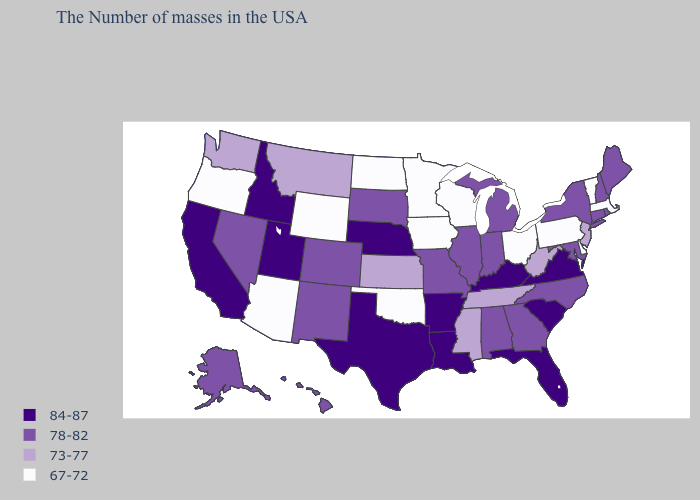Name the states that have a value in the range 84-87?
Write a very short answer. Virginia, South Carolina, Florida, Kentucky, Louisiana, Arkansas, Nebraska, Texas, Utah, Idaho, California. Does South Carolina have the highest value in the USA?
Keep it brief. Yes. What is the value of New Jersey?
Keep it brief. 73-77. What is the value of Nebraska?
Give a very brief answer. 84-87. How many symbols are there in the legend?
Concise answer only. 4. Does Iowa have the lowest value in the MidWest?
Write a very short answer. Yes. Does the first symbol in the legend represent the smallest category?
Keep it brief. No. Does New Jersey have the lowest value in the Northeast?
Short answer required. No. What is the value of Texas?
Write a very short answer. 84-87. Does Indiana have the highest value in the USA?
Be succinct. No. What is the lowest value in states that border Wisconsin?
Keep it brief. 67-72. What is the lowest value in the USA?
Answer briefly. 67-72. Name the states that have a value in the range 78-82?
Quick response, please. Maine, Rhode Island, New Hampshire, Connecticut, New York, Maryland, North Carolina, Georgia, Michigan, Indiana, Alabama, Illinois, Missouri, South Dakota, Colorado, New Mexico, Nevada, Alaska, Hawaii. Does West Virginia have the same value as Arkansas?
Give a very brief answer. No. What is the value of Hawaii?
Be succinct. 78-82. 